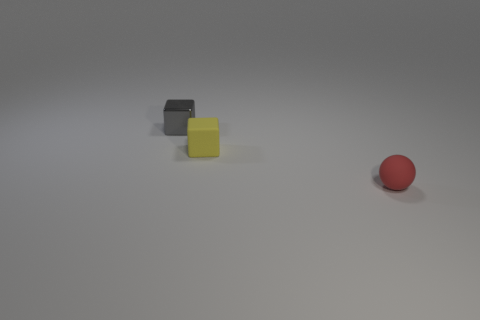Add 1 gray shiny blocks. How many objects exist? 4 Subtract all blocks. How many objects are left? 1 Subtract 0 cyan cylinders. How many objects are left? 3 Subtract all purple matte things. Subtract all tiny yellow matte cubes. How many objects are left? 2 Add 3 red matte objects. How many red matte objects are left? 4 Add 1 tiny yellow matte objects. How many tiny yellow matte objects exist? 2 